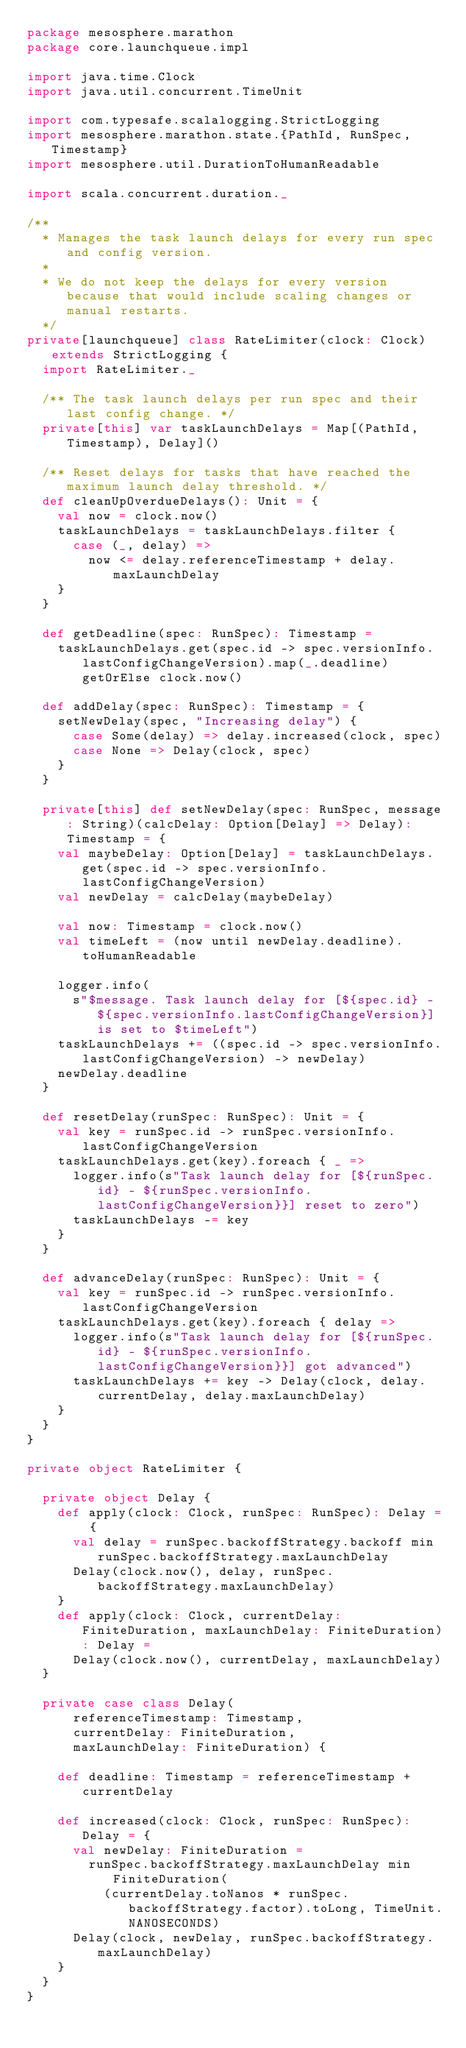Convert code to text. <code><loc_0><loc_0><loc_500><loc_500><_Scala_>package mesosphere.marathon
package core.launchqueue.impl

import java.time.Clock
import java.util.concurrent.TimeUnit

import com.typesafe.scalalogging.StrictLogging
import mesosphere.marathon.state.{PathId, RunSpec, Timestamp}
import mesosphere.util.DurationToHumanReadable

import scala.concurrent.duration._

/**
  * Manages the task launch delays for every run spec and config version.
  *
  * We do not keep the delays for every version because that would include scaling changes or manual restarts.
  */
private[launchqueue] class RateLimiter(clock: Clock) extends StrictLogging {
  import RateLimiter._

  /** The task launch delays per run spec and their last config change. */
  private[this] var taskLaunchDelays = Map[(PathId, Timestamp), Delay]()

  /** Reset delays for tasks that have reached the maximum launch delay threshold. */
  def cleanUpOverdueDelays(): Unit = {
    val now = clock.now()
    taskLaunchDelays = taskLaunchDelays.filter {
      case (_, delay) =>
        now <= delay.referenceTimestamp + delay.maxLaunchDelay
    }
  }

  def getDeadline(spec: RunSpec): Timestamp =
    taskLaunchDelays.get(spec.id -> spec.versionInfo.lastConfigChangeVersion).map(_.deadline) getOrElse clock.now()

  def addDelay(spec: RunSpec): Timestamp = {
    setNewDelay(spec, "Increasing delay") {
      case Some(delay) => delay.increased(clock, spec)
      case None => Delay(clock, spec)
    }
  }

  private[this] def setNewDelay(spec: RunSpec, message: String)(calcDelay: Option[Delay] => Delay): Timestamp = {
    val maybeDelay: Option[Delay] = taskLaunchDelays.get(spec.id -> spec.versionInfo.lastConfigChangeVersion)
    val newDelay = calcDelay(maybeDelay)

    val now: Timestamp = clock.now()
    val timeLeft = (now until newDelay.deadline).toHumanReadable

    logger.info(
      s"$message. Task launch delay for [${spec.id} - ${spec.versionInfo.lastConfigChangeVersion}] is set to $timeLeft")
    taskLaunchDelays += ((spec.id -> spec.versionInfo.lastConfigChangeVersion) -> newDelay)
    newDelay.deadline
  }

  def resetDelay(runSpec: RunSpec): Unit = {
    val key = runSpec.id -> runSpec.versionInfo.lastConfigChangeVersion
    taskLaunchDelays.get(key).foreach { _ =>
      logger.info(s"Task launch delay for [${runSpec.id} - ${runSpec.versionInfo.lastConfigChangeVersion}}] reset to zero")
      taskLaunchDelays -= key
    }
  }

  def advanceDelay(runSpec: RunSpec): Unit = {
    val key = runSpec.id -> runSpec.versionInfo.lastConfigChangeVersion
    taskLaunchDelays.get(key).foreach { delay =>
      logger.info(s"Task launch delay for [${runSpec.id} - ${runSpec.versionInfo.lastConfigChangeVersion}}] got advanced")
      taskLaunchDelays += key -> Delay(clock, delay.currentDelay, delay.maxLaunchDelay)
    }
  }
}

private object RateLimiter {

  private object Delay {
    def apply(clock: Clock, runSpec: RunSpec): Delay = {
      val delay = runSpec.backoffStrategy.backoff min runSpec.backoffStrategy.maxLaunchDelay
      Delay(clock.now(), delay, runSpec.backoffStrategy.maxLaunchDelay)
    }
    def apply(clock: Clock, currentDelay: FiniteDuration, maxLaunchDelay: FiniteDuration): Delay =
      Delay(clock.now(), currentDelay, maxLaunchDelay)
  }

  private case class Delay(
      referenceTimestamp: Timestamp,
      currentDelay: FiniteDuration,
      maxLaunchDelay: FiniteDuration) {

    def deadline: Timestamp = referenceTimestamp + currentDelay

    def increased(clock: Clock, runSpec: RunSpec): Delay = {
      val newDelay: FiniteDuration =
        runSpec.backoffStrategy.maxLaunchDelay min FiniteDuration(
          (currentDelay.toNanos * runSpec.backoffStrategy.factor).toLong, TimeUnit.NANOSECONDS)
      Delay(clock, newDelay, runSpec.backoffStrategy.maxLaunchDelay)
    }
  }
}
</code> 